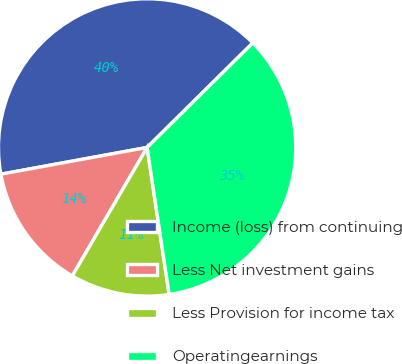Convert chart to OTSL. <chart><loc_0><loc_0><loc_500><loc_500><pie_chart><fcel>Income (loss) from continuing<fcel>Less Net investment gains<fcel>Less Provision for income tax<fcel>Operatingearnings<nl><fcel>40.47%<fcel>13.73%<fcel>10.76%<fcel>35.05%<nl></chart> 